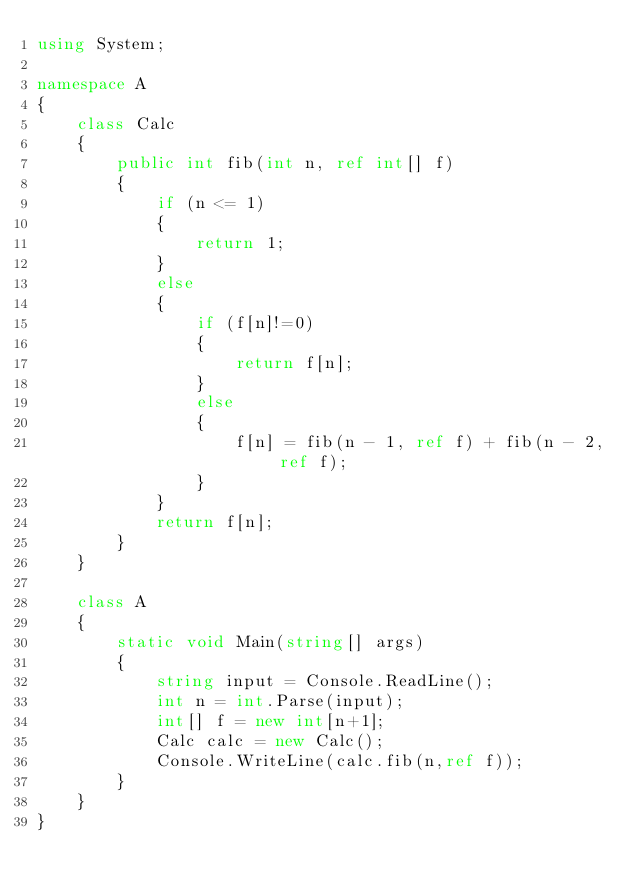<code> <loc_0><loc_0><loc_500><loc_500><_C#_>using System;

namespace A
{
    class Calc
    {
        public int fib(int n, ref int[] f)
        {
            if (n <= 1)
            {
                return 1;
            }
            else
            {
                if (f[n]!=0)
                {
                    return f[n];
                }
                else
                {
                    f[n] = fib(n - 1, ref f) + fib(n - 2, ref f);
                }
            }
            return f[n];
        }
    }

    class A
    {
        static void Main(string[] args)
        {
            string input = Console.ReadLine();
            int n = int.Parse(input);
            int[] f = new int[n+1];
            Calc calc = new Calc();
            Console.WriteLine(calc.fib(n,ref f));
        }
    }
}

</code> 